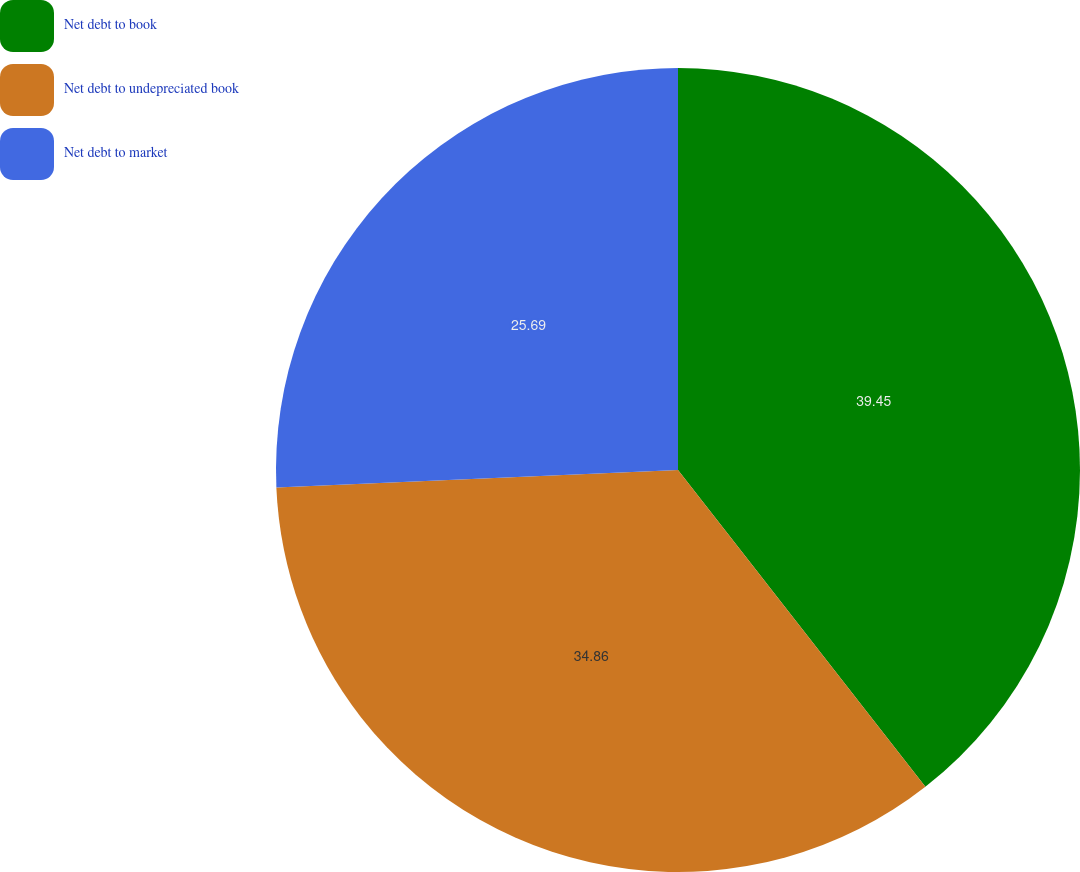Convert chart to OTSL. <chart><loc_0><loc_0><loc_500><loc_500><pie_chart><fcel>Net debt to book<fcel>Net debt to undepreciated book<fcel>Net debt to market<nl><fcel>39.45%<fcel>34.86%<fcel>25.69%<nl></chart> 